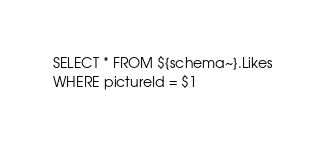Convert code to text. <code><loc_0><loc_0><loc_500><loc_500><_SQL_>SELECT * FROM ${schema~}.Likes
WHERE pictureId = $1</code> 